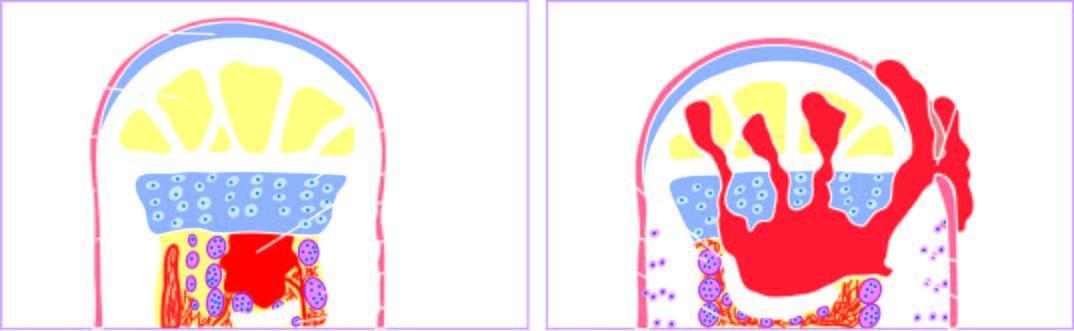does the extension of infection into the joint space, epiphysis and the skin produce a draining sinus?
Answer the question using a single word or phrase. Yes 